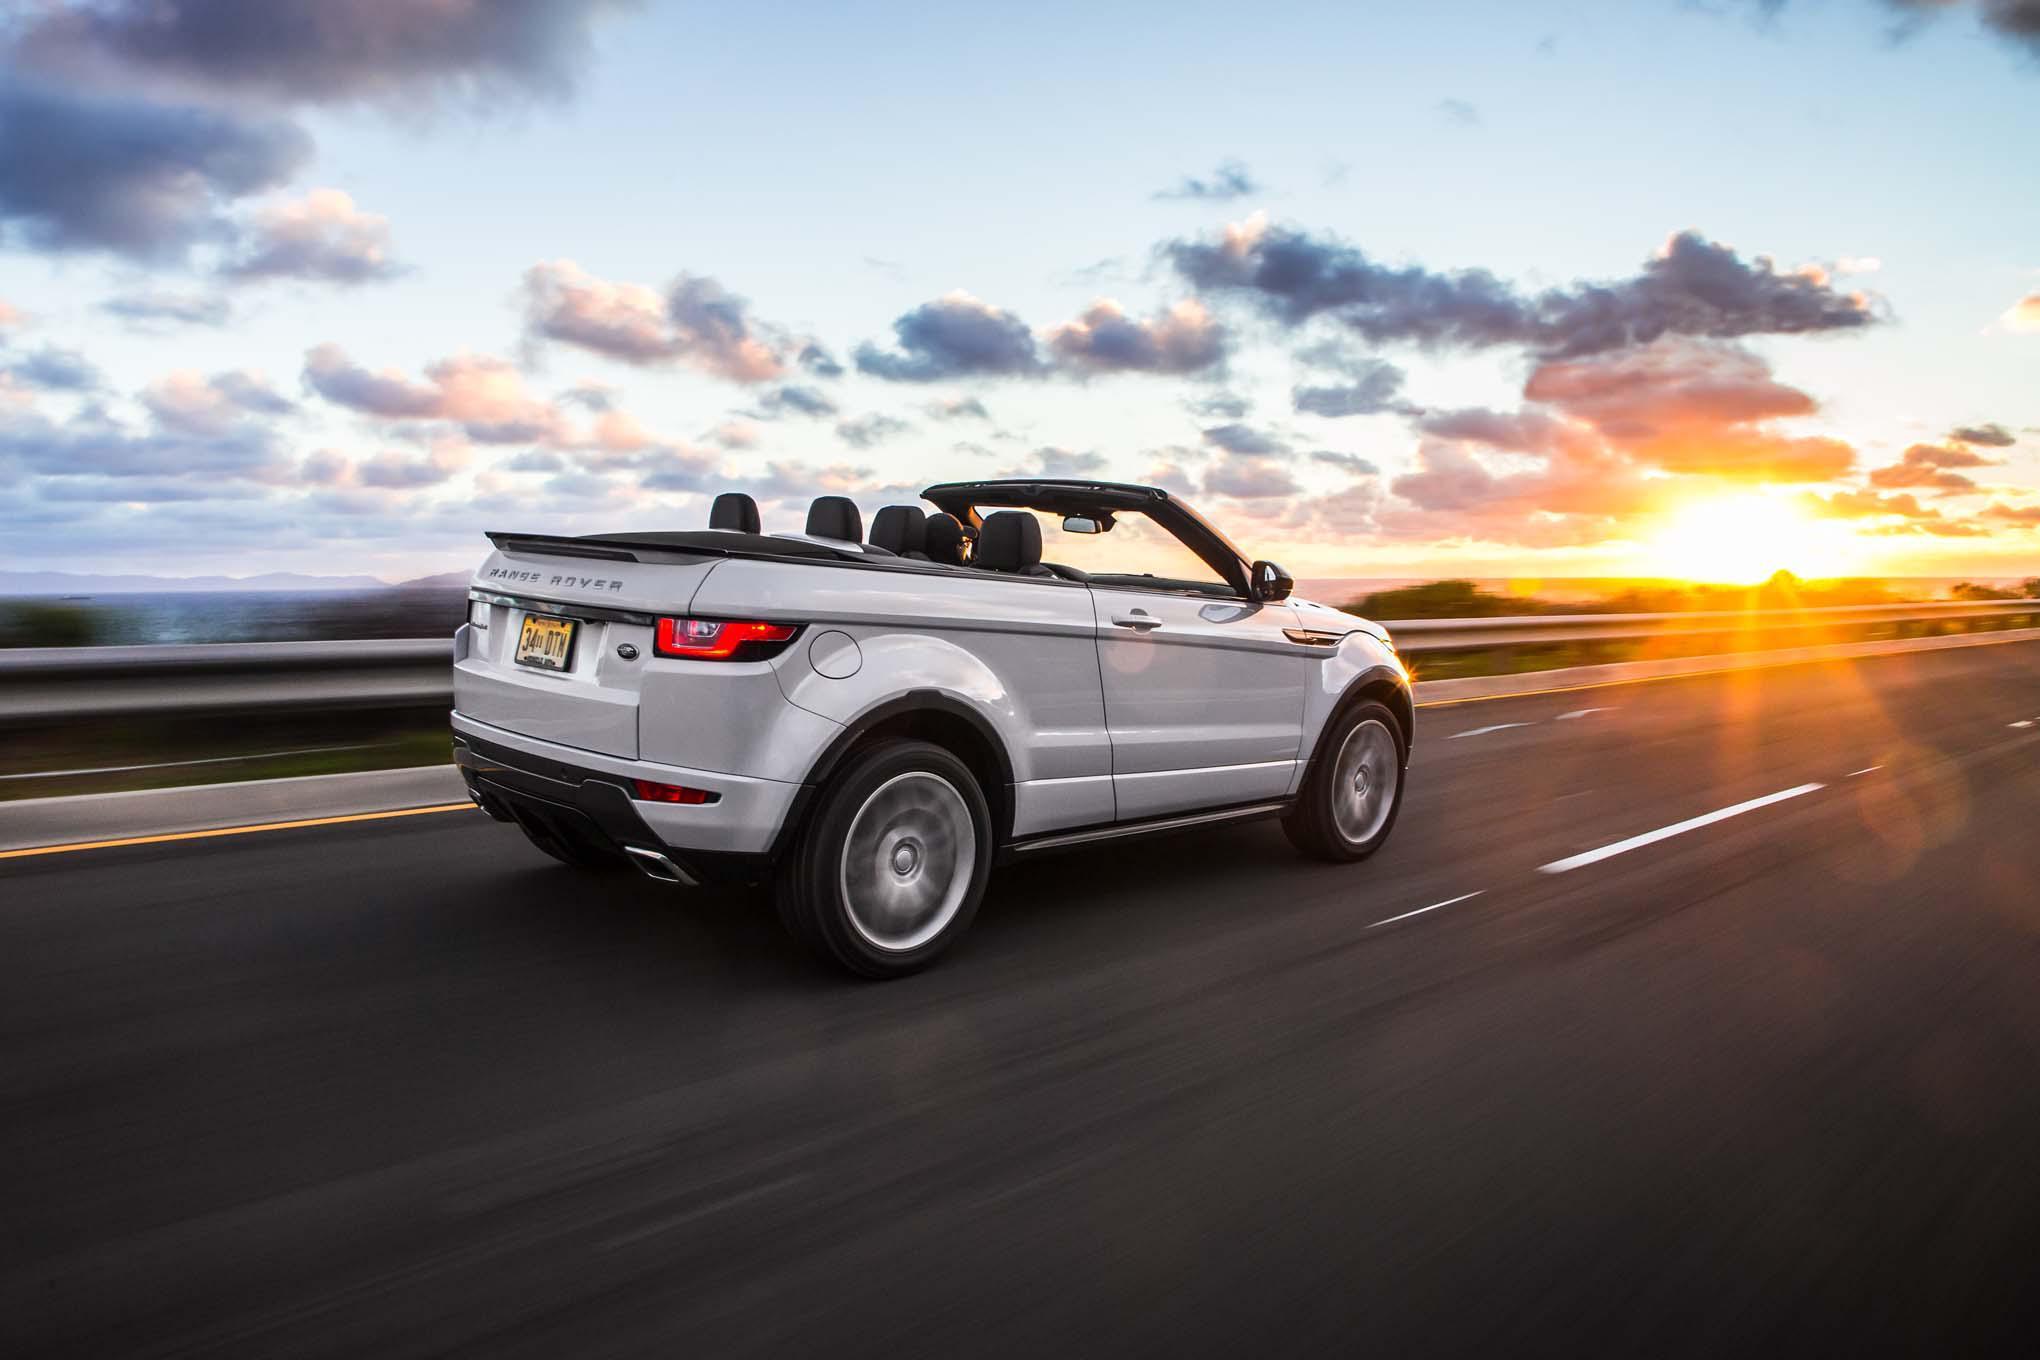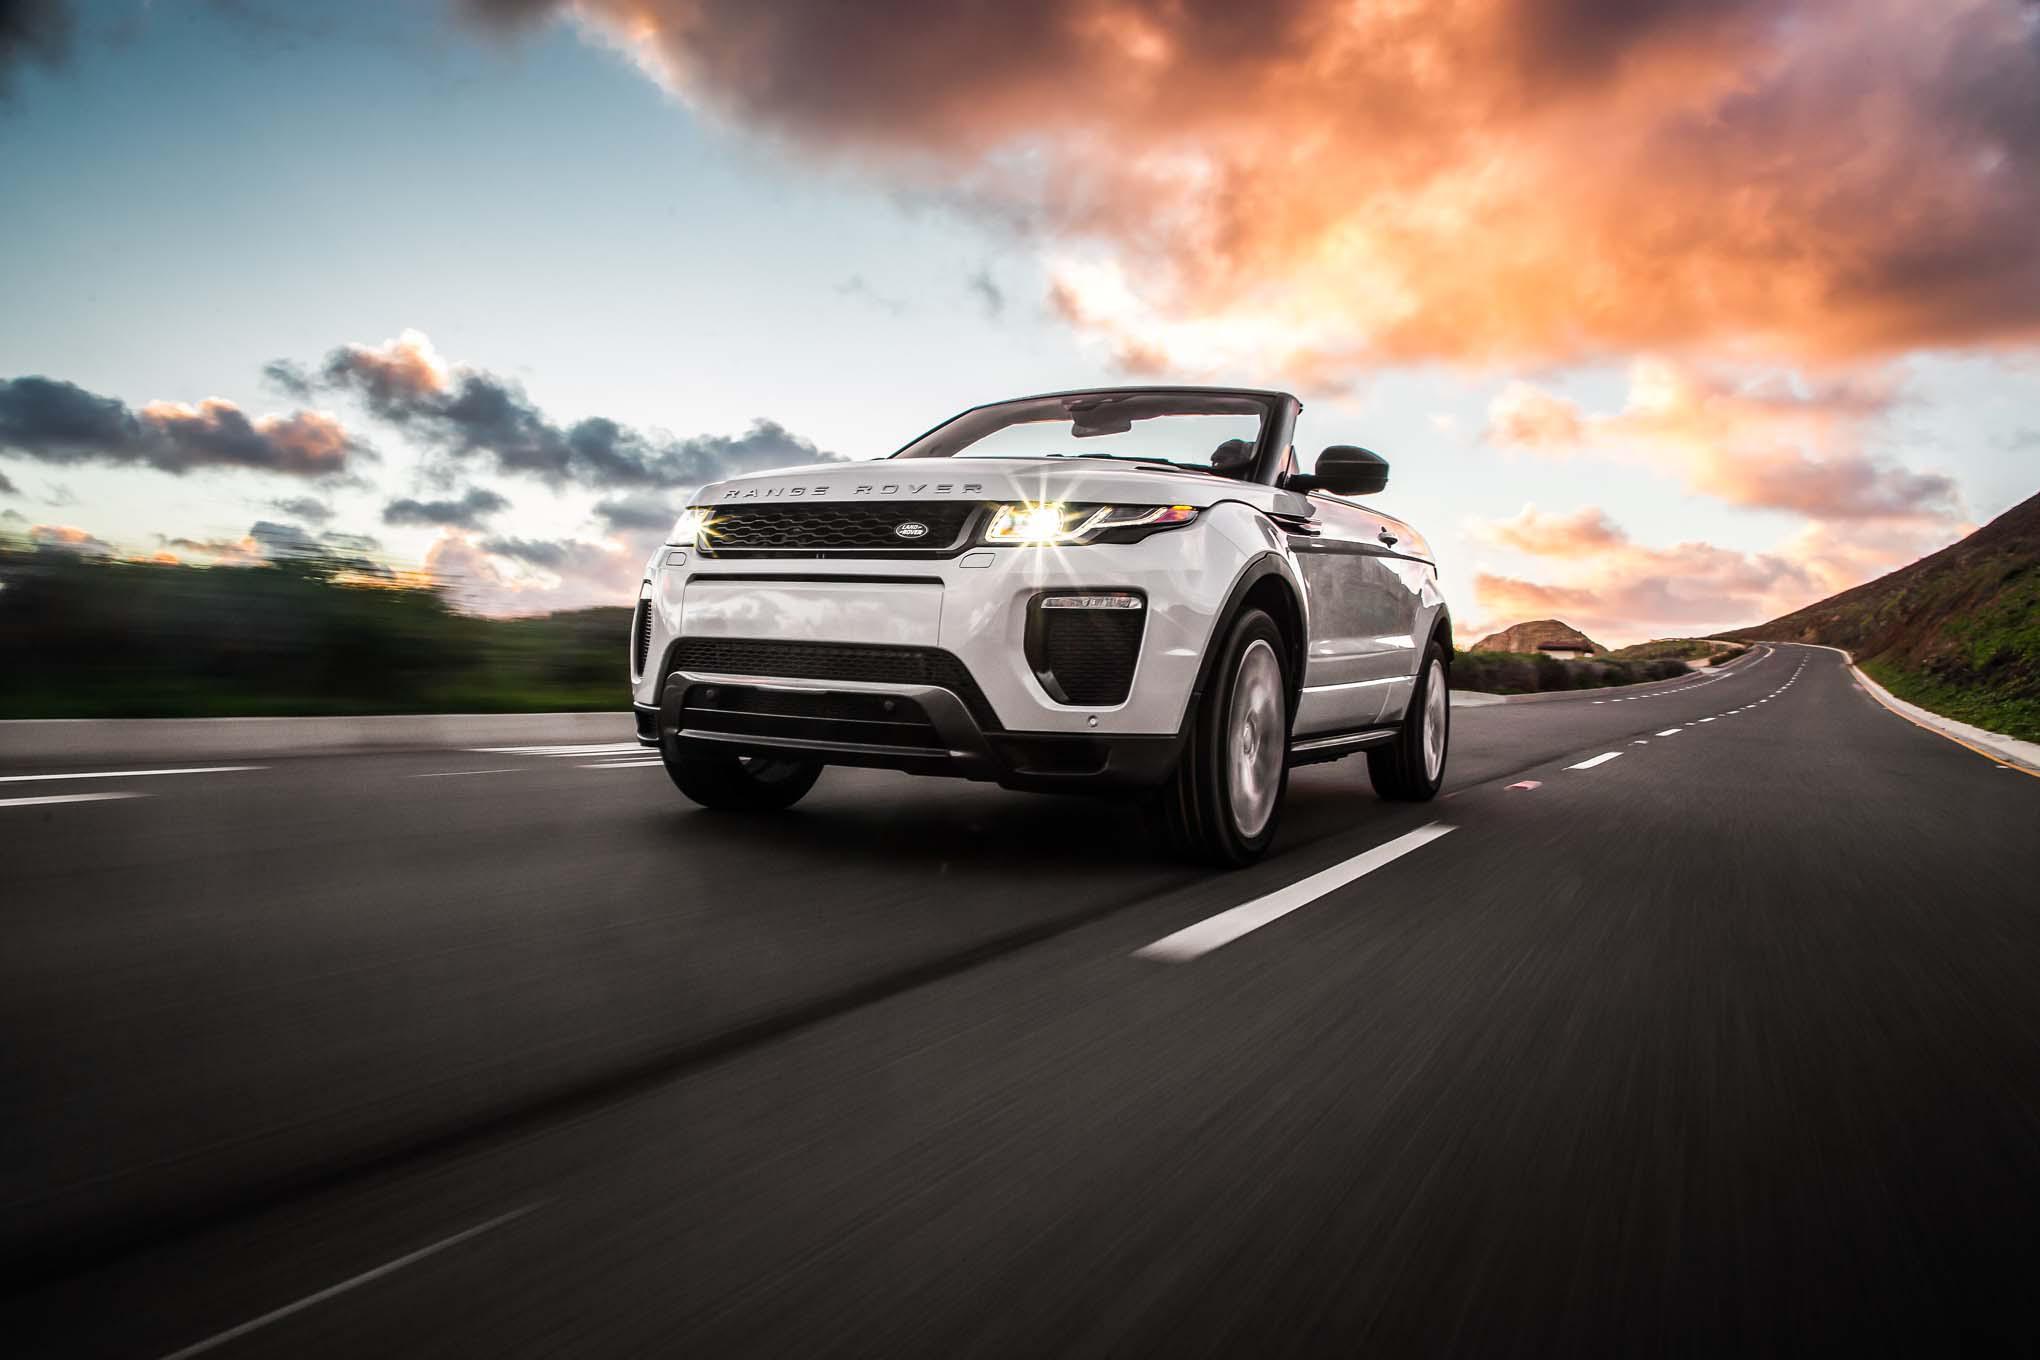The first image is the image on the left, the second image is the image on the right. Evaluate the accuracy of this statement regarding the images: "There is one orange convertible with the top down and one white convertible with the top down". Is it true? Answer yes or no. No. The first image is the image on the left, the second image is the image on the right. Analyze the images presented: Is the assertion "An image shows an orange convertible, which has its top down." valid? Answer yes or no. No. 